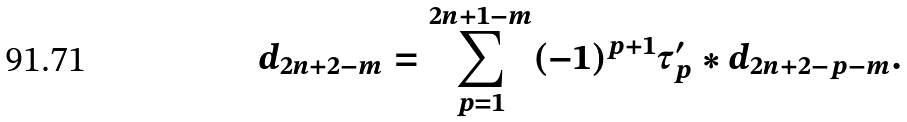Convert formula to latex. <formula><loc_0><loc_0><loc_500><loc_500>d _ { 2 n + 2 - m } = \sum _ { p = 1 } ^ { 2 n + 1 - m } ( - 1 ) ^ { p + 1 } \tau _ { p } ^ { \prime } * d _ { 2 n + 2 - p - m } .</formula> 